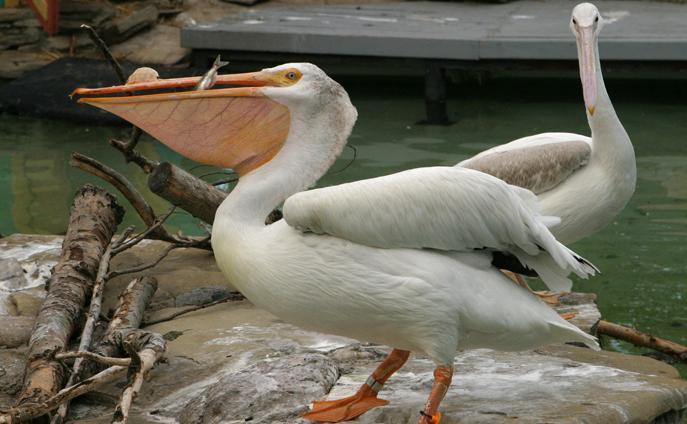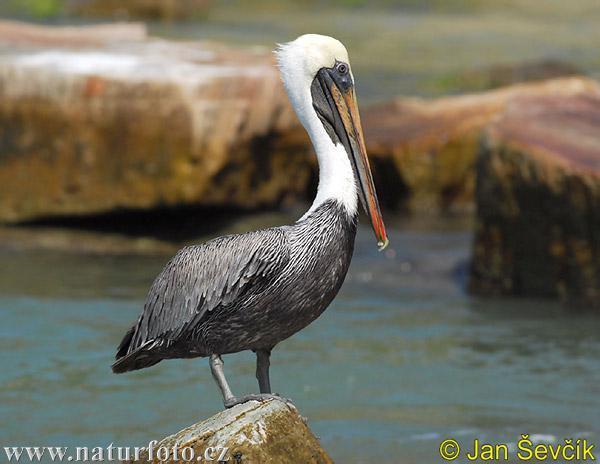The first image is the image on the left, the second image is the image on the right. For the images shown, is this caption "A fish is in a bird's mouth." true? Answer yes or no. Yes. 